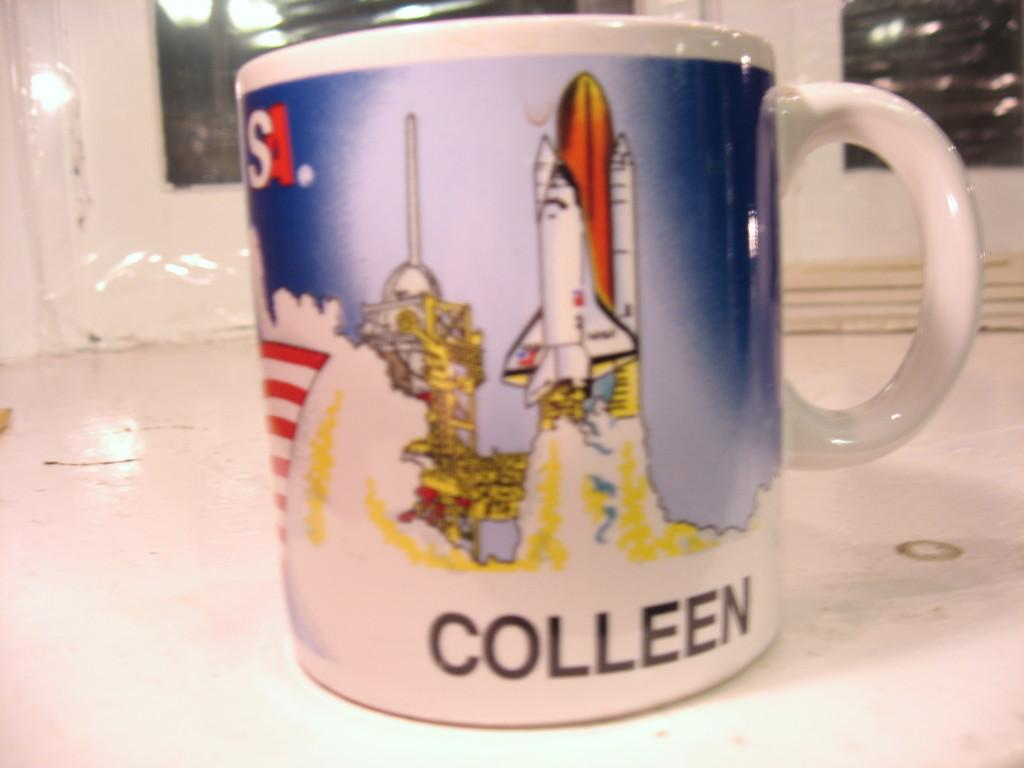<image>
Share a concise interpretation of the image provided. White cup with a space ship and the name COLLEEN on the bottom. 